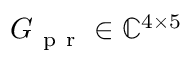Convert formula to latex. <formula><loc_0><loc_0><loc_500><loc_500>G _ { p r } \in \mathbb { C } ^ { 4 \times 5 }</formula> 